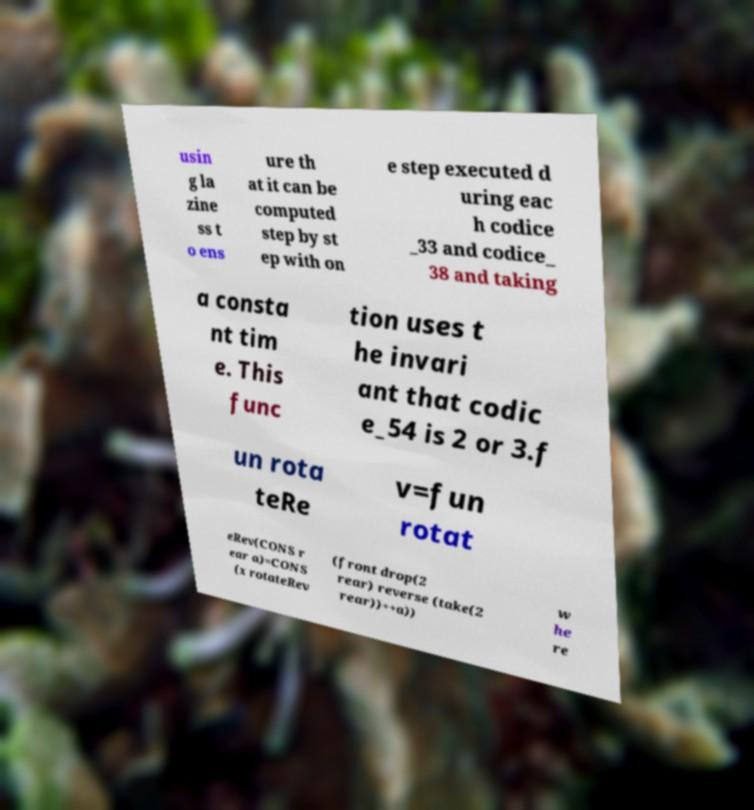Please read and relay the text visible in this image. What does it say? usin g la zine ss t o ens ure th at it can be computed step by st ep with on e step executed d uring eac h codice _33 and codice_ 38 and taking a consta nt tim e. This func tion uses t he invari ant that codic e_54 is 2 or 3.f un rota teRe v=fun rotat eRev(CONS r ear a)=CONS (x rotateRev (front drop(2 rear) reverse (take(2 rear))++a)) w he re 